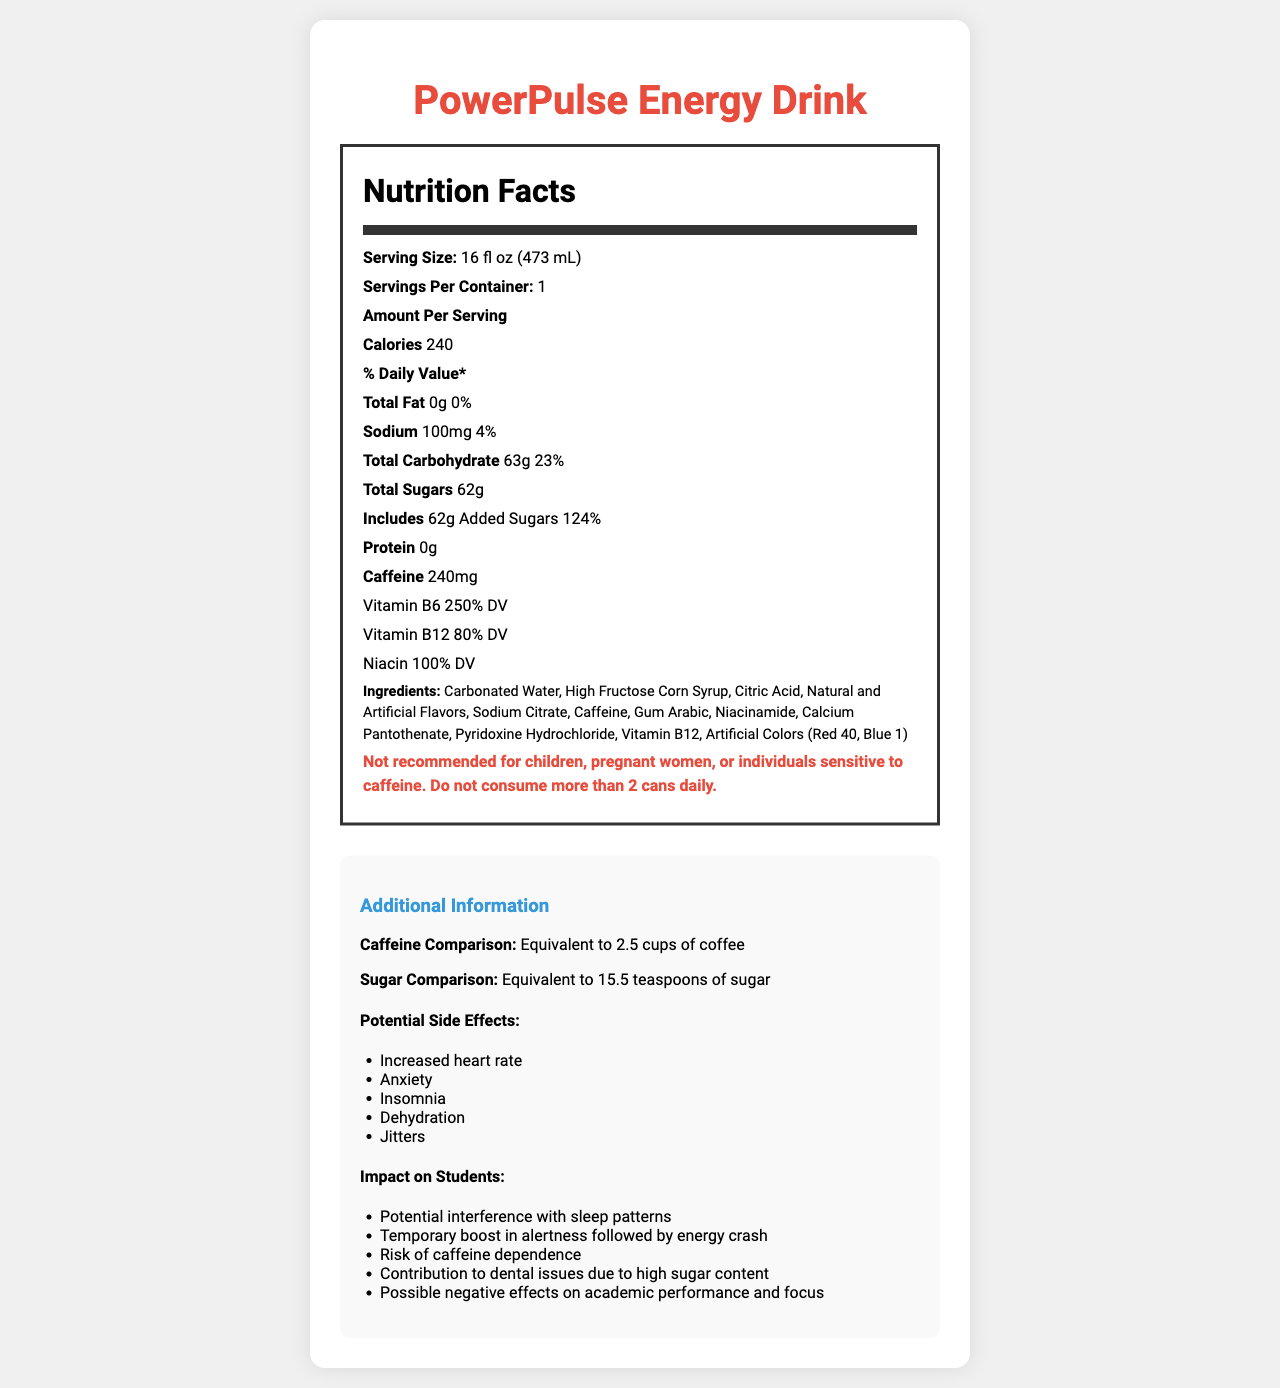what is the serving size? The serving size is listed as "16 fl oz (473 mL)" on the label.
Answer: 16 fl oz (473 mL) how many calories are in one serving? The nutrition label states that there are 240 calories per serving.
Answer: 240 calories what is the total amount of sugars in one serving? The label indicates that the total sugars in one serving are 62g.
Answer: 62g how much caffeine is in one serving? The nutrition label specifies 240mg of caffeine per serving.
Answer: 240mg what percentage of the daily value of vitamin B6 does one serving provide? The label shows that one serving provides 250% of the daily value for vitamin B6.
Answer: 250% DV which of the following is an ingredient in PowerPulse Energy Drink? A. Vitamin C B. High Fructose Corn Syrup C. Green Tea Extract D. Guarana The ingredients list includes "High Fructose Corn Syrup" but does not mention Vitamin C, Green Tea Extract, or Guarana.
Answer: B how does the caffeine content in one serving compare to cups of coffee? The additional information on the label states that the caffeine content is equivalent to 2.5 cups of coffee.
Answer: Equivalent to 2.5 cups of coffee is the product recommended for children? (yes/no) The warning on the label explicitly states that it is "Not recommended for children."
Answer: No what is the total carbohydrate content per serving? The nutrition label lists the total carbohydrate content as 63g per serving.
Answer: 63g how many servings are there per container? The label states that there is 1 serving per container.
Answer: 1 which of the following potential side effects is *not* mentioned in the document? A. Increased heart rate B. Dizziness C. Insomnia D. Anxiety The label lists "Increased heart rate," "Insomnia," and "Anxiety" but does not mention "Dizziness."
Answer: B why could this energy drink be problematic for students? The additional information section highlights several impacts on students, such as potential interference with sleep patterns, temporary boost in alertness followed by an energy crash, risk of caffeine dependence, contribution to dental issues due to high sugar content, and possible negative effects on academic performance and focus.
Answer: It may interfere with sleep patterns, cause dental issues, lead to caffeine dependence, and affect academic performance. how much sodium is in a serving? The nutrition label lists 100mg of sodium per serving.
Answer: 100mg can you determine the cost of this energy drink from the document? The document does not provide any information about the price of the energy drink.
Answer: Cannot be determined what are the primary concerns associated with the sugar content in this energy drink? The document indicates that the high sugar content can contribute to dental issues, and the added sugars make up 124% of the daily value.
Answer: Dental issues and high added sugar content summarize the main idea of the document. The document includes detailed nutrition facts, ingredients, warnings, additional information on caffeine and sugar comparisons, potential side effects, and impacts specific to students, emphasizing the concerns with its consumption.
Answer: The document presents the nutritional information of PowerPulse Energy Drink, highlighting its high caffeine and sugar content, potential impacts on health and students, including possible side effects and warnings. 